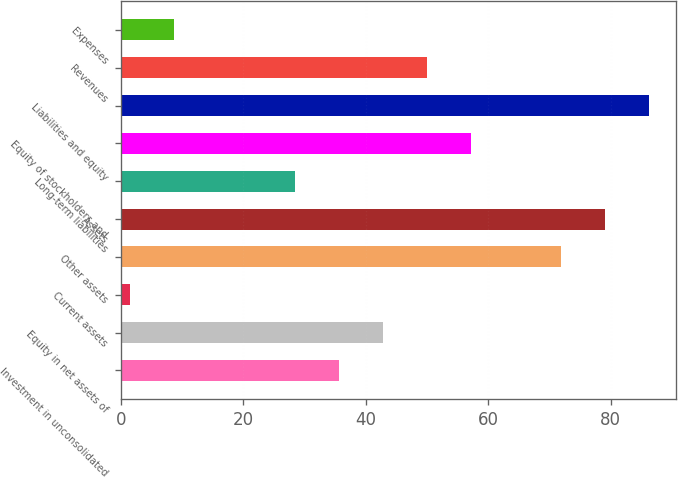<chart> <loc_0><loc_0><loc_500><loc_500><bar_chart><fcel>Investment in unconsolidated<fcel>Equity in net assets of<fcel>Current assets<fcel>Other assets<fcel>Assets<fcel>Long-term liabilities<fcel>Equity of stockholders and<fcel>Liabilities and equity<fcel>Revenues<fcel>Expenses<nl><fcel>35.58<fcel>42.77<fcel>1.4<fcel>71.9<fcel>79.09<fcel>28.39<fcel>57.15<fcel>86.28<fcel>49.96<fcel>8.59<nl></chart> 